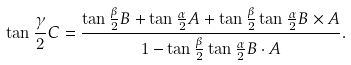<formula> <loc_0><loc_0><loc_500><loc_500>\tan { \frac { \gamma } { 2 } } C = { \frac { \tan { \frac { \beta } { 2 } } B + \tan { \frac { \alpha } { 2 } } A + \tan { \frac { \beta } { 2 } } \tan { \frac { \alpha } { 2 } } B \times A } { 1 - \tan { \frac { \beta } { 2 } } \tan { \frac { \alpha } { 2 } } B \cdot A } } .</formula> 